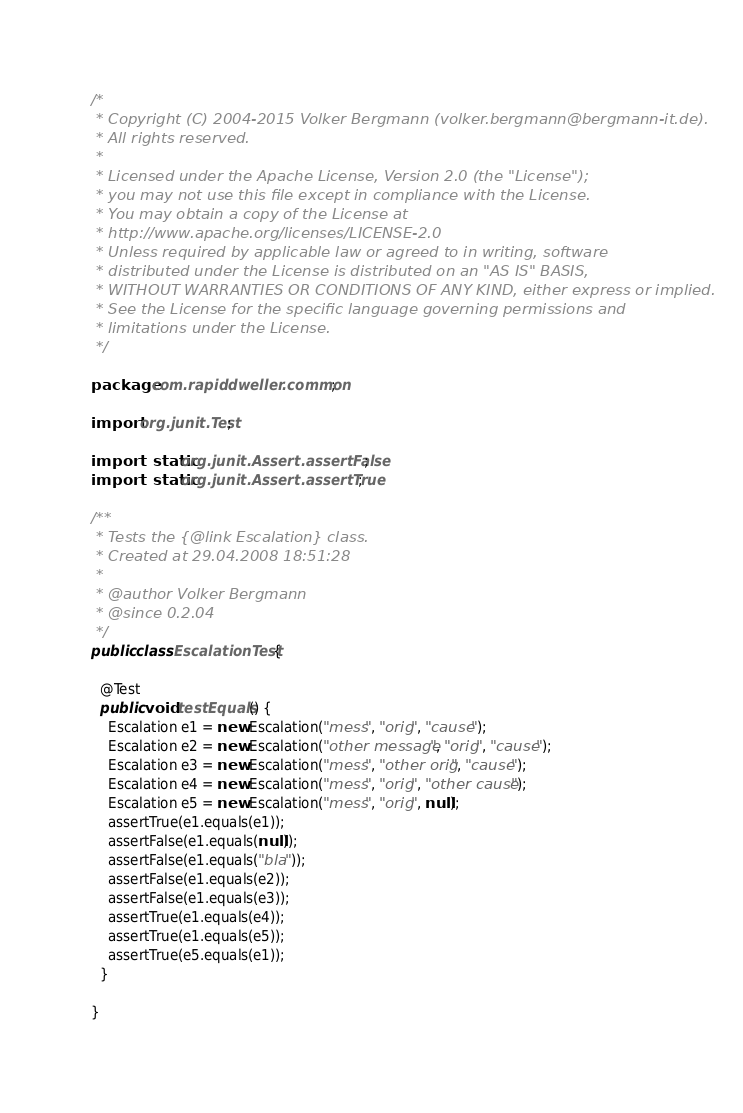Convert code to text. <code><loc_0><loc_0><loc_500><loc_500><_Java_>/*
 * Copyright (C) 2004-2015 Volker Bergmann (volker.bergmann@bergmann-it.de).
 * All rights reserved.
 *
 * Licensed under the Apache License, Version 2.0 (the "License");
 * you may not use this file except in compliance with the License.
 * You may obtain a copy of the License at
 * http://www.apache.org/licenses/LICENSE-2.0
 * Unless required by applicable law or agreed to in writing, software
 * distributed under the License is distributed on an "AS IS" BASIS,
 * WITHOUT WARRANTIES OR CONDITIONS OF ANY KIND, either express or implied.
 * See the License for the specific language governing permissions and
 * limitations under the License.
 */

package com.rapiddweller.common;

import org.junit.Test;

import static org.junit.Assert.assertFalse;
import static org.junit.Assert.assertTrue;

/**
 * Tests the {@link Escalation} class.
 * Created at 29.04.2008 18:51:28
 *
 * @author Volker Bergmann
 * @since 0.2.04
 */
public class EscalationTest {

  @Test
  public void testEquals() {
    Escalation e1 = new Escalation("mess", "orig", "cause");
    Escalation e2 = new Escalation("other message", "orig", "cause");
    Escalation e3 = new Escalation("mess", "other orig", "cause");
    Escalation e4 = new Escalation("mess", "orig", "other cause");
    Escalation e5 = new Escalation("mess", "orig", null);
    assertTrue(e1.equals(e1));
    assertFalse(e1.equals(null));
    assertFalse(e1.equals("bla"));
    assertFalse(e1.equals(e2));
    assertFalse(e1.equals(e3));
    assertTrue(e1.equals(e4));
    assertTrue(e1.equals(e5));
    assertTrue(e5.equals(e1));
  }

}
</code> 